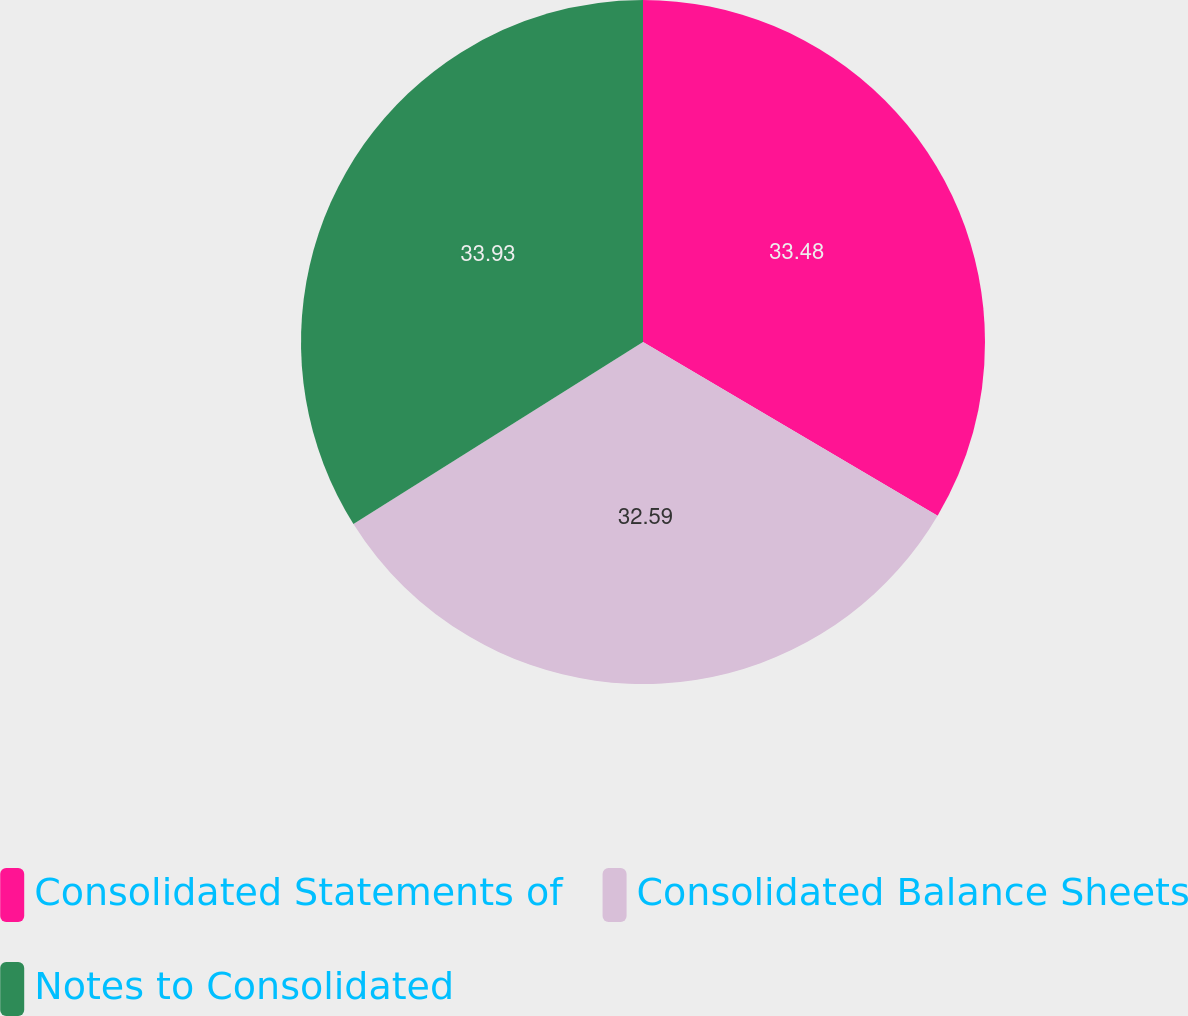Convert chart to OTSL. <chart><loc_0><loc_0><loc_500><loc_500><pie_chart><fcel>Consolidated Statements of<fcel>Consolidated Balance Sheets<fcel>Notes to Consolidated<nl><fcel>33.48%<fcel>32.59%<fcel>33.93%<nl></chart> 